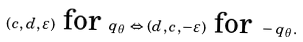<formula> <loc_0><loc_0><loc_500><loc_500>( c , d , \varepsilon ) \text { for } q _ { \theta } \Leftrightarrow ( d , c , - \varepsilon ) \text { for } - q _ { \theta } .</formula> 